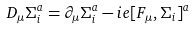<formula> <loc_0><loc_0><loc_500><loc_500>D _ { \mu } \Sigma _ { i } ^ { a } = \partial _ { \mu } \Sigma _ { i } ^ { a } - i e [ F _ { \mu } , \Sigma _ { i } ] ^ { a }</formula> 